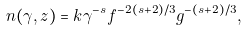<formula> <loc_0><loc_0><loc_500><loc_500>n ( \gamma , z ) = k \gamma ^ { - s } f ^ { - 2 ( s + 2 ) / 3 } g ^ { - ( s + 2 ) / 3 } ,</formula> 